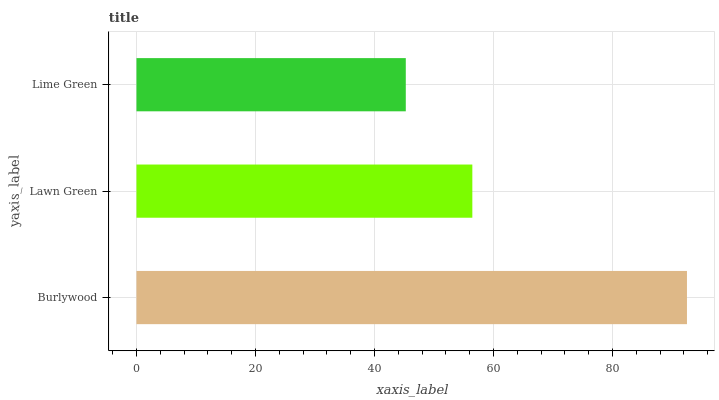Is Lime Green the minimum?
Answer yes or no. Yes. Is Burlywood the maximum?
Answer yes or no. Yes. Is Lawn Green the minimum?
Answer yes or no. No. Is Lawn Green the maximum?
Answer yes or no. No. Is Burlywood greater than Lawn Green?
Answer yes or no. Yes. Is Lawn Green less than Burlywood?
Answer yes or no. Yes. Is Lawn Green greater than Burlywood?
Answer yes or no. No. Is Burlywood less than Lawn Green?
Answer yes or no. No. Is Lawn Green the high median?
Answer yes or no. Yes. Is Lawn Green the low median?
Answer yes or no. Yes. Is Lime Green the high median?
Answer yes or no. No. Is Burlywood the low median?
Answer yes or no. No. 